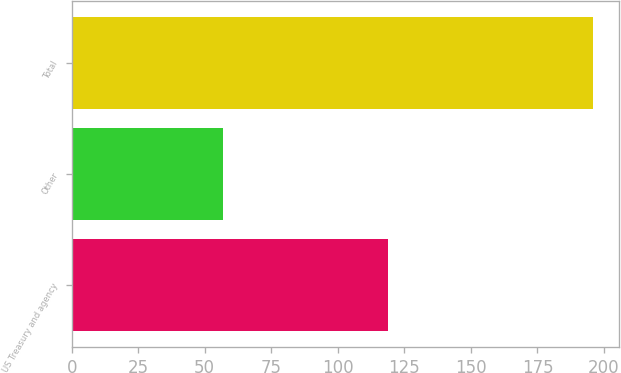Convert chart to OTSL. <chart><loc_0><loc_0><loc_500><loc_500><bar_chart><fcel>US Treasury and agency<fcel>Other<fcel>Total<nl><fcel>119<fcel>57<fcel>196<nl></chart> 